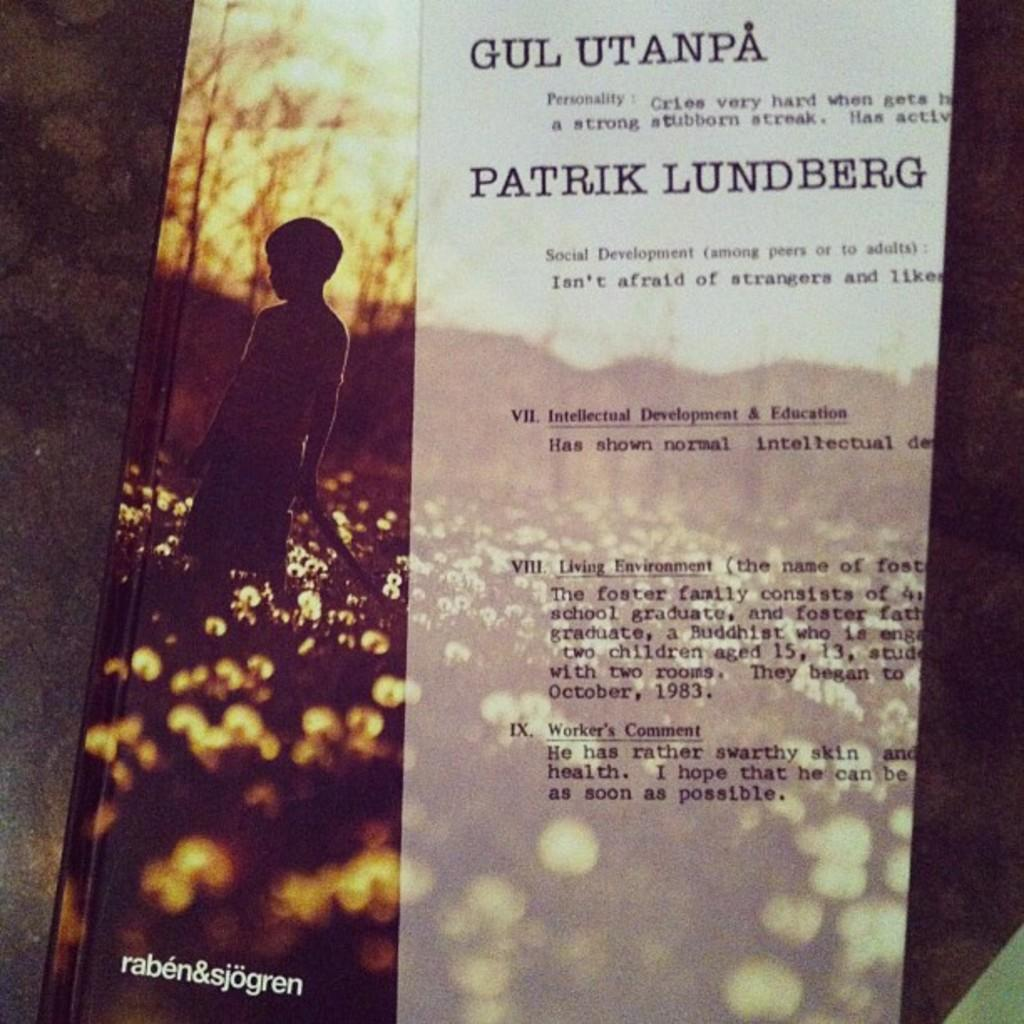<image>
Share a concise interpretation of the image provided. The cover of a book titled Gul Utanpa on top. 